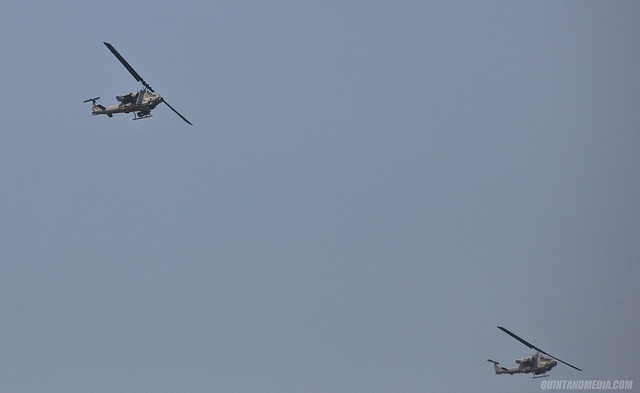Describe the objects in this image and their specific colors. I can see airplane in gray, black, and darkgray tones and airplane in gray and black tones in this image. 